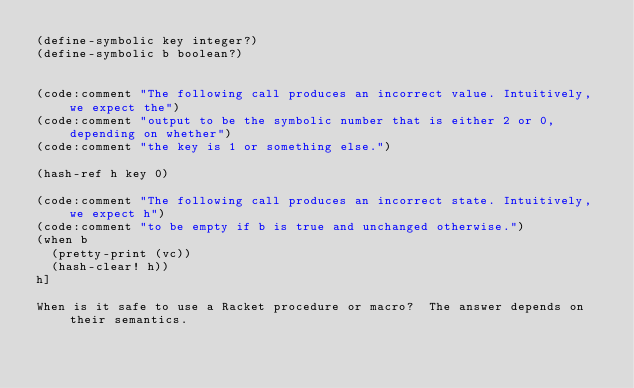Convert code to text. <code><loc_0><loc_0><loc_500><loc_500><_Racket_>(define-symbolic key integer?)
(define-symbolic b boolean?)


(code:comment "The following call produces an incorrect value. Intuitively, we expect the")
(code:comment "output to be the symbolic number that is either 2 or 0, depending on whether")
(code:comment "the key is 1 or something else.")

(hash-ref h key 0)

(code:comment "The following call produces an incorrect state. Intuitively, we expect h")
(code:comment "to be empty if b is true and unchanged otherwise.")
(when b
  (pretty-print (vc))
  (hash-clear! h))
h]  

When is it safe to use a Racket procedure or macro?  The answer depends on their semantics.  </code> 